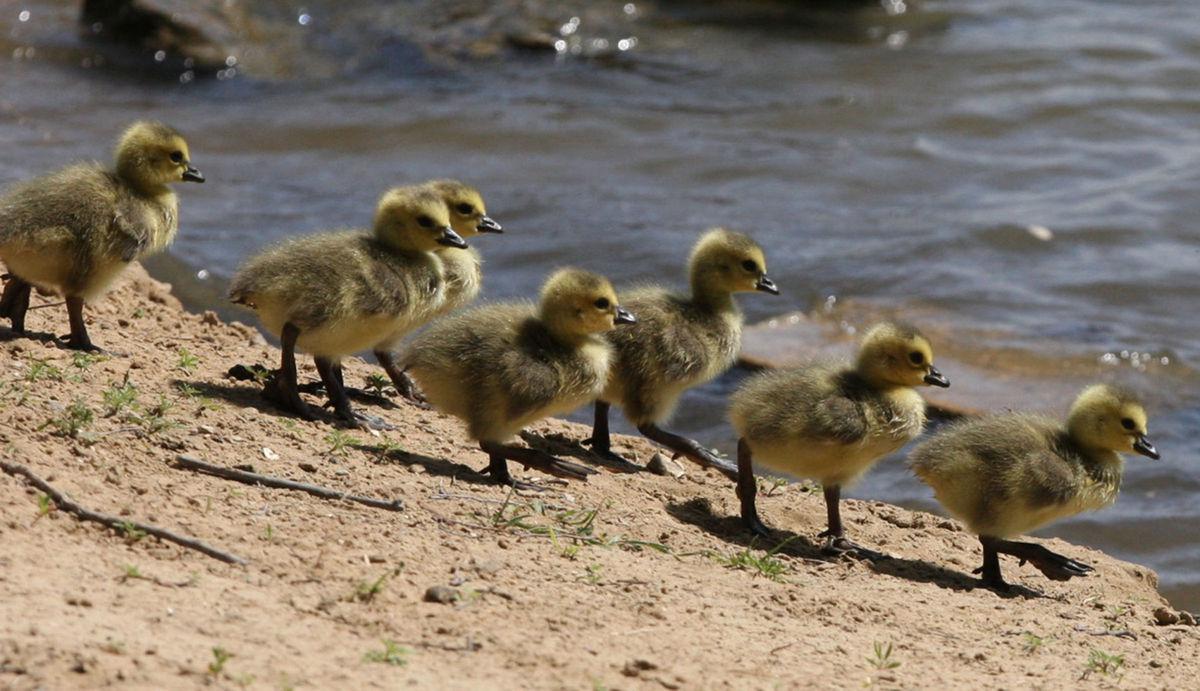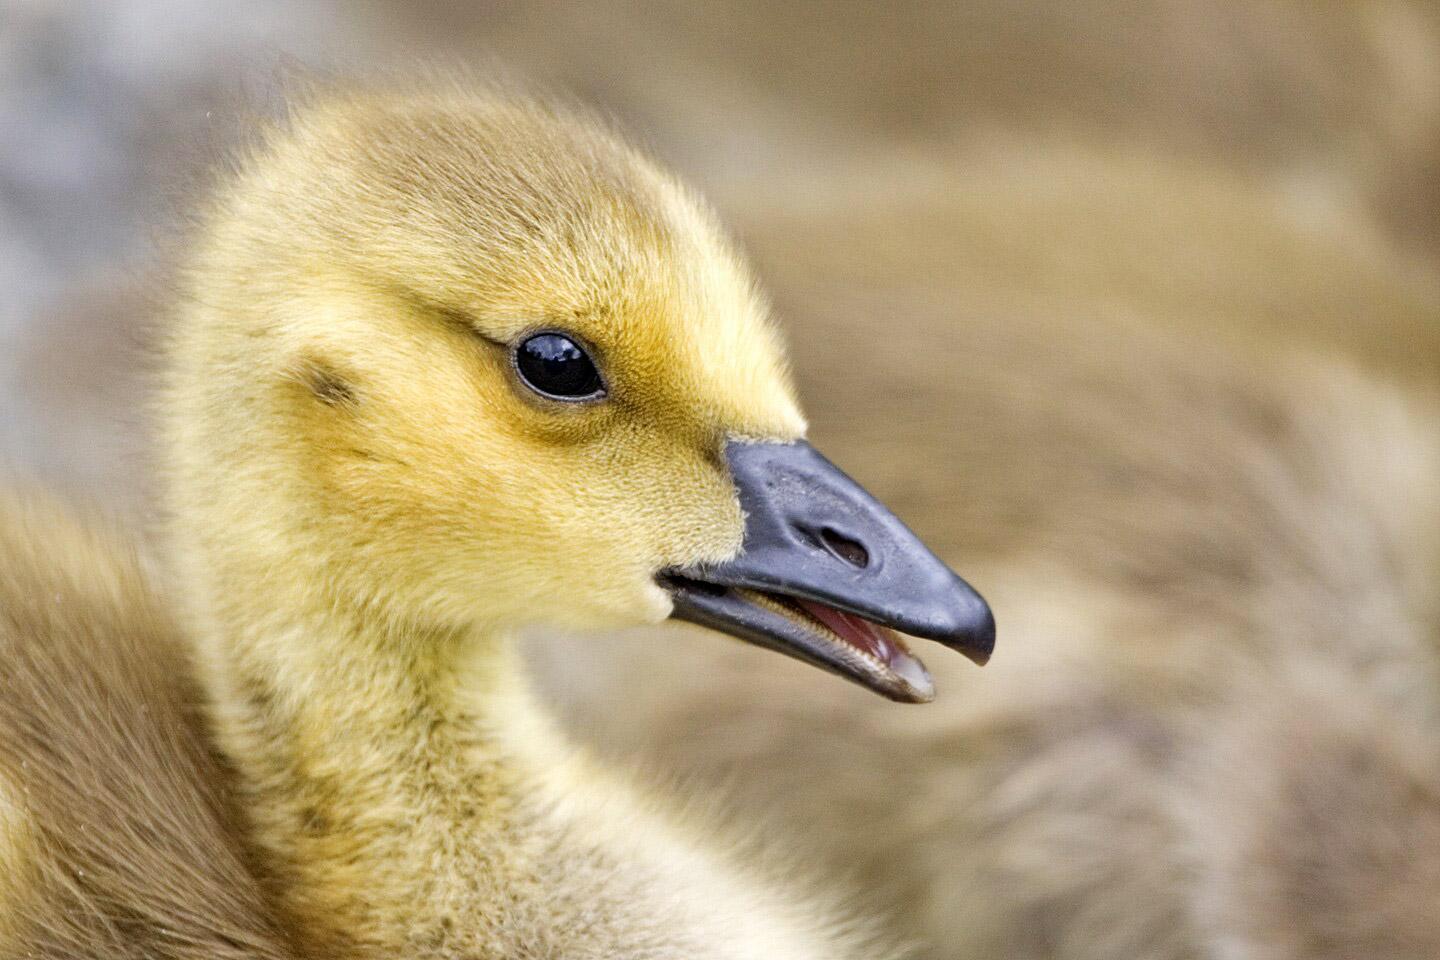The first image is the image on the left, the second image is the image on the right. For the images shown, is this caption "There are two adult geese leading no more than seven ducking." true? Answer yes or no. No. The first image is the image on the left, the second image is the image on the right. Considering the images on both sides, is "The ducks in the left image are all facing towards the right." valid? Answer yes or no. Yes. 